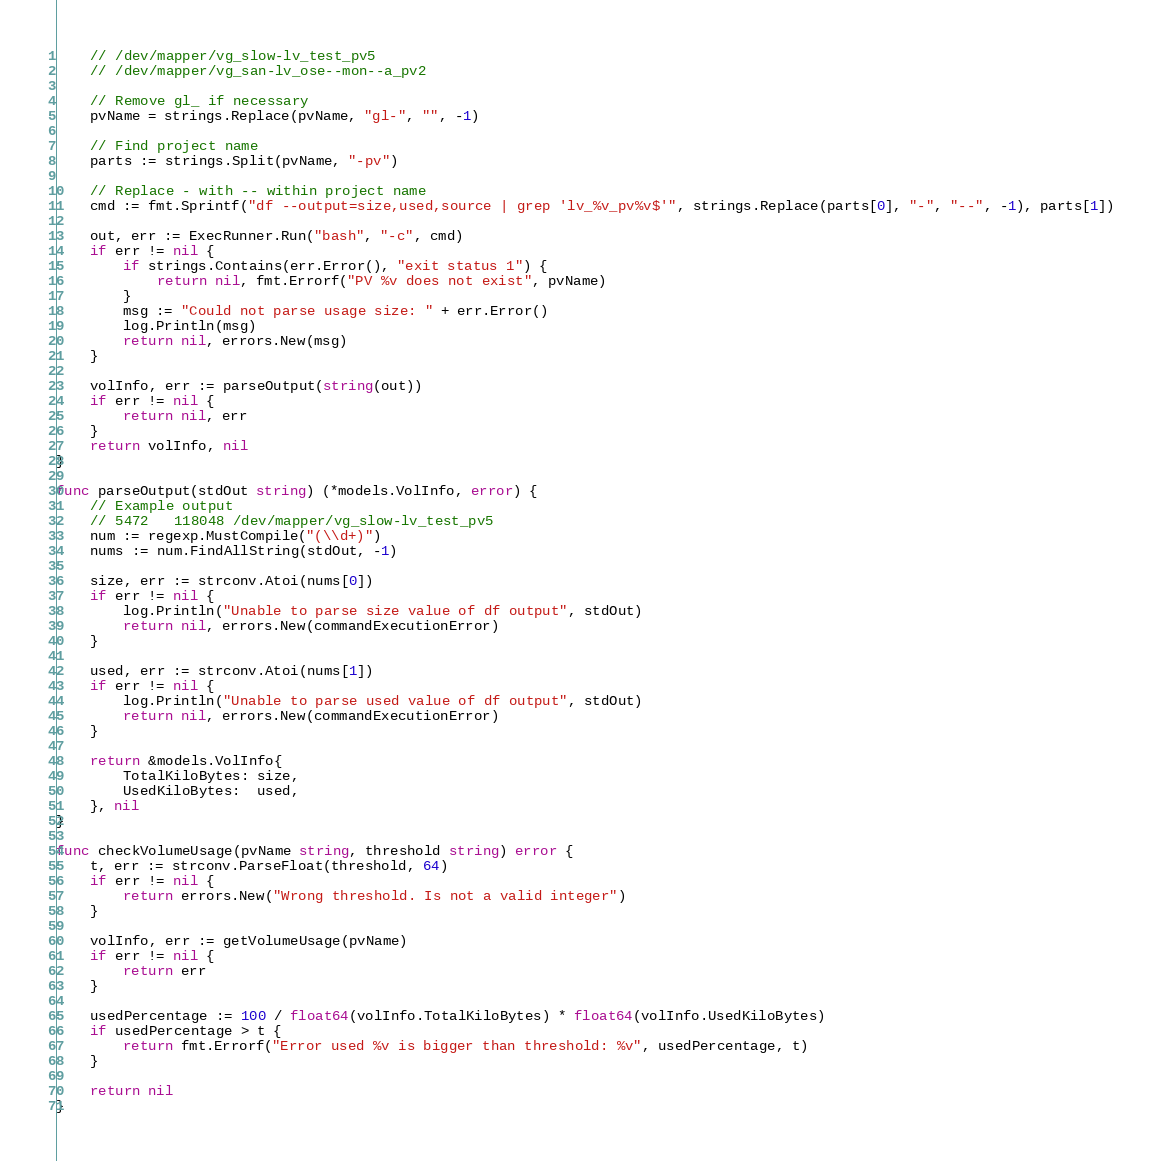Convert code to text. <code><loc_0><loc_0><loc_500><loc_500><_Go_>	// /dev/mapper/vg_slow-lv_test_pv5
	// /dev/mapper/vg_san-lv_ose--mon--a_pv2

	// Remove gl_ if necessary
	pvName = strings.Replace(pvName, "gl-", "", -1)

	// Find project name
	parts := strings.Split(pvName, "-pv")

	// Replace - with -- within project name
	cmd := fmt.Sprintf("df --output=size,used,source | grep 'lv_%v_pv%v$'", strings.Replace(parts[0], "-", "--", -1), parts[1])

	out, err := ExecRunner.Run("bash", "-c", cmd)
	if err != nil {
		if strings.Contains(err.Error(), "exit status 1") {
			return nil, fmt.Errorf("PV %v does not exist", pvName)
		}
		msg := "Could not parse usage size: " + err.Error()
		log.Println(msg)
		return nil, errors.New(msg)
	}

	volInfo, err := parseOutput(string(out))
	if err != nil {
		return nil, err
	}
	return volInfo, nil
}

func parseOutput(stdOut string) (*models.VolInfo, error) {
	// Example output
	// 5472   118048 /dev/mapper/vg_slow-lv_test_pv5
	num := regexp.MustCompile("(\\d+)")
	nums := num.FindAllString(stdOut, -1)

	size, err := strconv.Atoi(nums[0])
	if err != nil {
		log.Println("Unable to parse size value of df output", stdOut)
		return nil, errors.New(commandExecutionError)
	}

	used, err := strconv.Atoi(nums[1])
	if err != nil {
		log.Println("Unable to parse used value of df output", stdOut)
		return nil, errors.New(commandExecutionError)
	}

	return &models.VolInfo{
		TotalKiloBytes: size,
		UsedKiloBytes:  used,
	}, nil
}

func checkVolumeUsage(pvName string, threshold string) error {
	t, err := strconv.ParseFloat(threshold, 64)
	if err != nil {
		return errors.New("Wrong threshold. Is not a valid integer")
	}

	volInfo, err := getVolumeUsage(pvName)
	if err != nil {
		return err
	}

	usedPercentage := 100 / float64(volInfo.TotalKiloBytes) * float64(volInfo.UsedKiloBytes)
	if usedPercentage > t {
		return fmt.Errorf("Error used %v is bigger than threshold: %v", usedPercentage, t)
	}

	return nil
}
</code> 